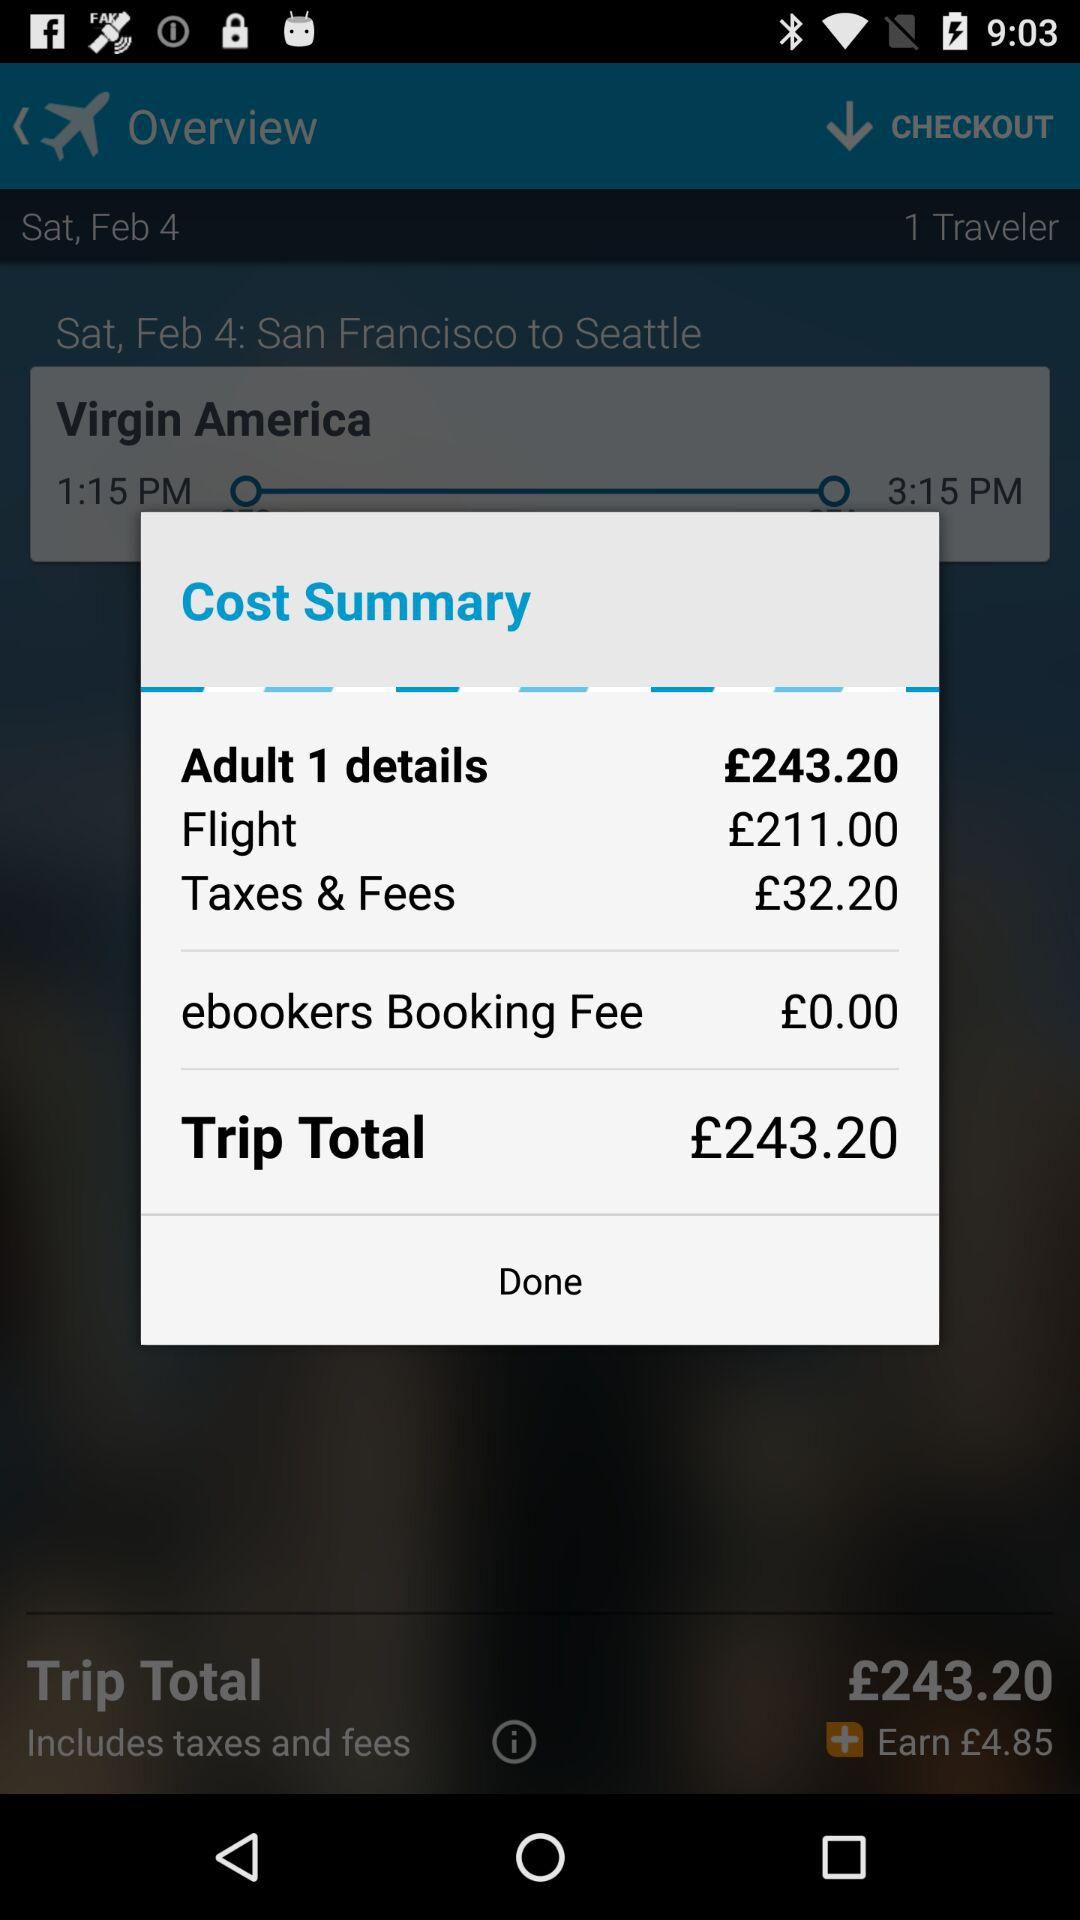What is the flight ticket price? The flight ticket price is £243.20. 